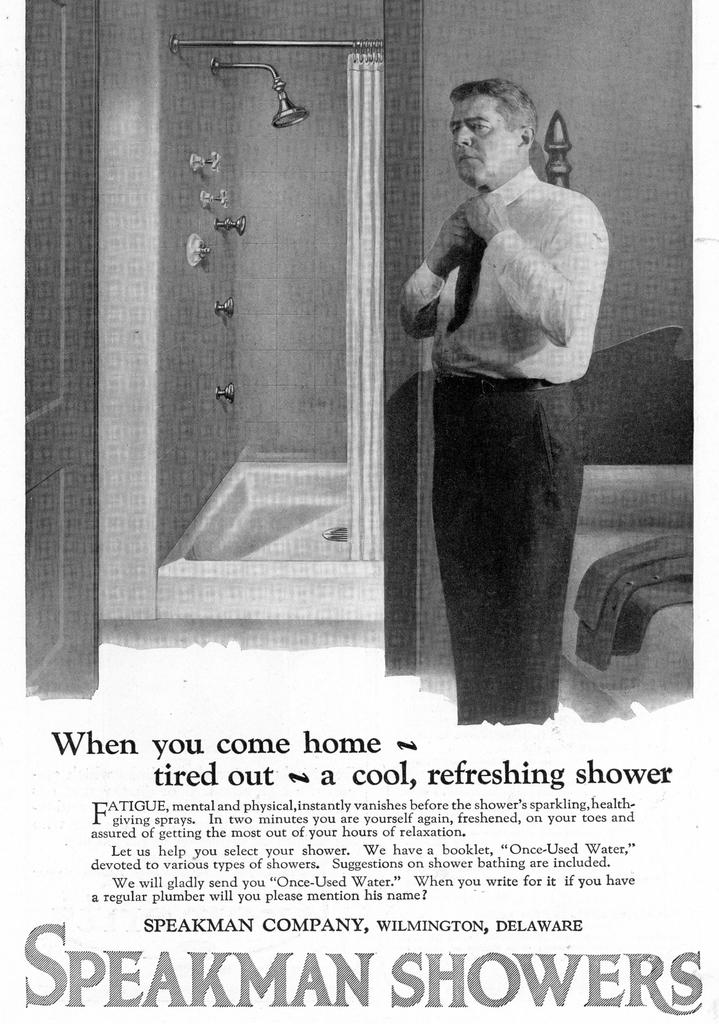<image>
Relay a brief, clear account of the picture shown. Vintage add for SpeakMan Showers stating that When you come home-tired out-a cool, refreshing shower Fatigue, mental and physical will vanish. 